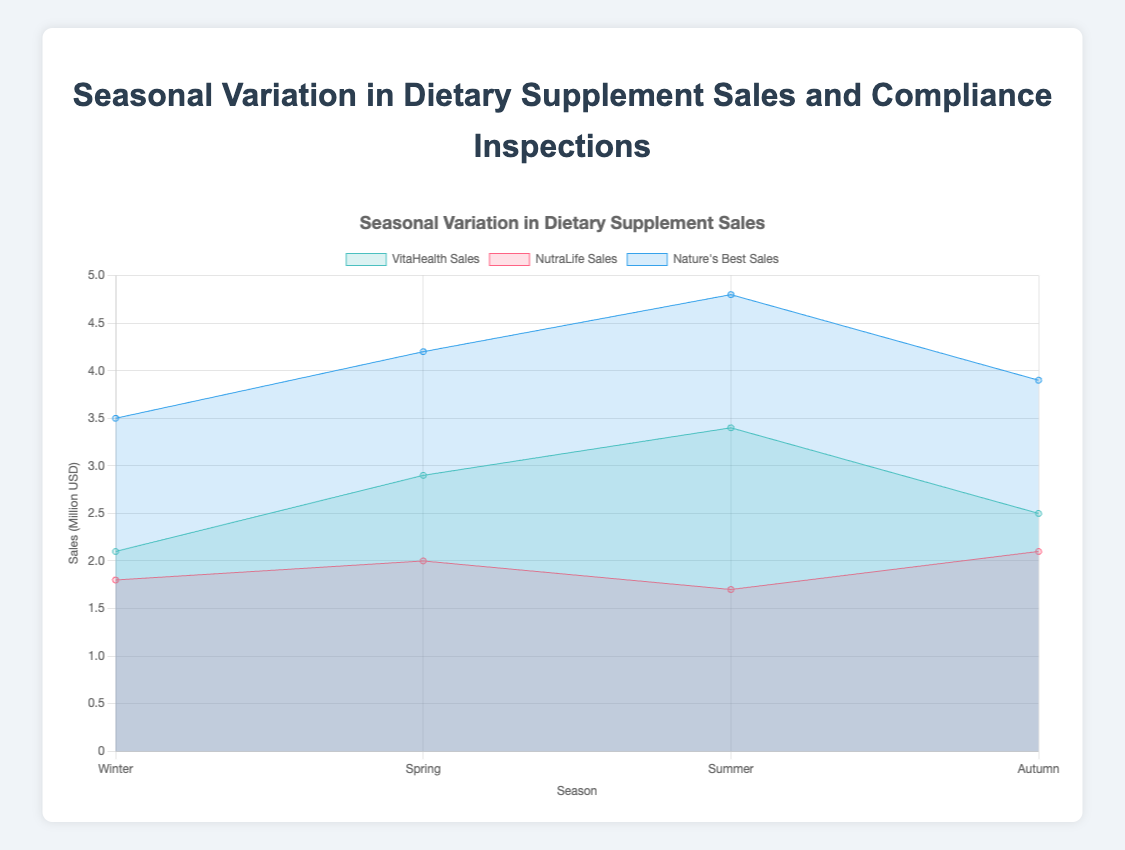What is the title of the chart? The title of the chart is shown at the top of the figure. It helps to quickly identify the main topic or the dataset being visualized.
Answer: Seasonal Variation in Dietary Supplement Sales Which company has the highest sales in Summer? By looking at the peak points for each dataset in the Summer section of the area chart, "Nature's Best" has the highest sales reaching around 4.8 million USD.
Answer: Nature's Best Which season shows the highest number of compliance inspections for VitaHealth? By examining the tooltip or label details for VitaHealth, the highest number of compliance inspections occurs in Summer with 4 inspections.
Answer: Summer What is the total sales for NutraLife in Winter and Autumn? Add the sales values for NutraLife in Winter (1.8 million USD) and Autumn (2.1 million USD). The sum is 1.8 + 2.1 = 3.9 million USD.
Answer: 3.9 million USD Compare the sales of NutraLife between Spring and Summer. Which season has lower sales? By comparing the values on the area chart, NutraLife has sales of 2.0 million USD in Spring and 1.7 million USD in Summer. Summer has lower sales.
Answer: Summer What is the difference in compliance inspections for Nature's Best between Winter and Summer? The number of compliance inspections for Nature's Best is 4 in Winter and 5 in Summer. The difference is 5 - 4 = 1 inspection.
Answer: 1 inspection What is the average sales of VitaHealth across all seasons? To find the average, sum the sales for VitaHealth across all seasons (2.1 + 2.9 + 3.4 + 2.5) and divide by the number of seasons, i.e., (2.1 + 2.9 + 3.4 + 2.5) / 4 = 2.725 million USD.
Answer: 2.725 million USD Which company had the most stable (least variation in) sales across the seasons? By observing the area chart, NutraLife's sales show the least variation, hovering between 1.7 and 2.1 million USD.
Answer: NutraLife How does the number of compliance inspections change for Nature's Best from Spring to Autumn? Examine the compliance inspections for Nature's Best: 3 in Spring and 4 in Autumn. It increases by 1 inspection.
Answer: Increase by 1 inspection 